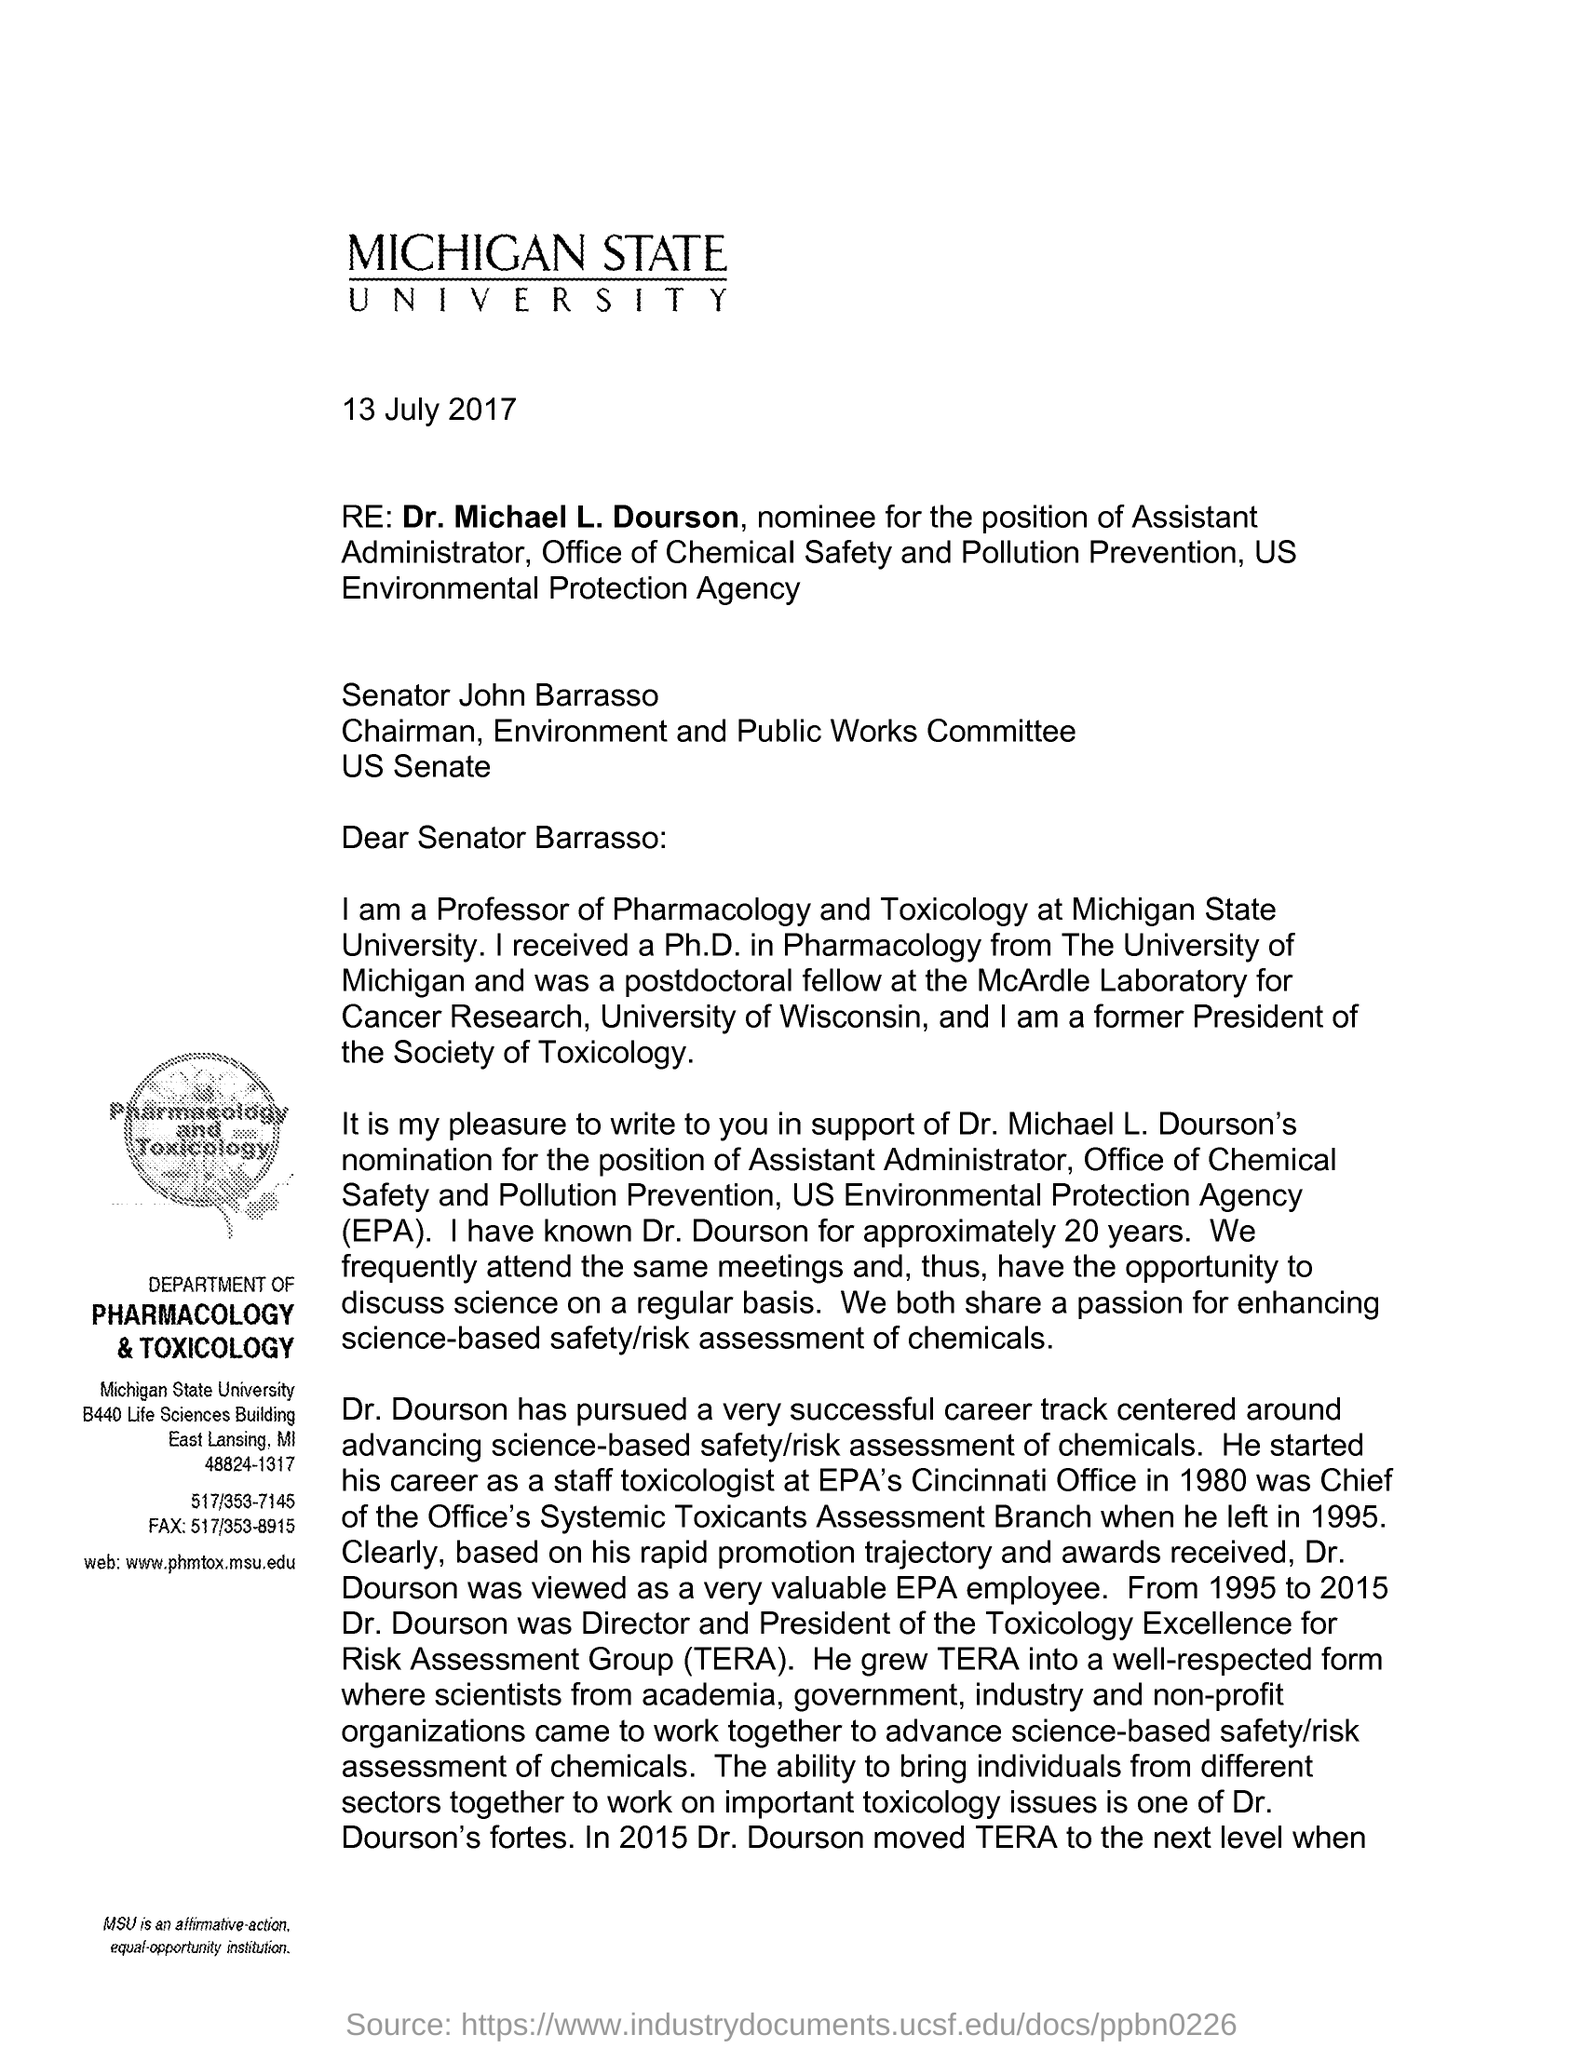Indicate a few pertinent items in this graphic. The US Environmental Protection Agency (EPA) is an agency of the federal government responsible for protecting human health and the environment. TERA stands for Toxicology Excellence for Risk Assessment Group. The website of the Department of Pharmacology & Toxicology at Michigan State University is [www.phmtox.msu.edu](http://www.phmtox.msu.edu). Dr. Dourson was the Director and President of the TERA from 1995 to 2015. The letter head mentions Michigan State University. 